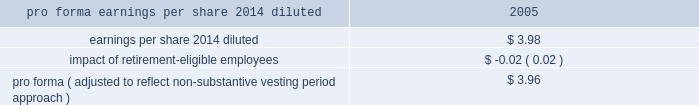The table adjusts the revised diluted earnings per share for 2005 from the preceding table to reflect the approximate impact of using the non-substantive vesting period approach for these periods .
Stock-based compensation .
Pro forma ( adjusted to reflect non-substantive vesting period approach ) $ 3.96 note 16 .
Business segments effective in the first quarter of 2007 , 3m made certain changes to its business segments in its continuing effort to drive growth by aligning businesses around markets and customers .
The most significant of these changes are summarized as follows : 2022 3m 2019s new emerging business opportunity in its track and trace initiative resulted in the merging of a number of formerly separate efforts into one concerted effort for future growth .
Track and trace has a growing array of applications 2013 from tracking packages to managing medical and legal records .
The establishment of this new initiative within 3m 2019s safety , security and protection services segment resulted in the transfer of certain businesses to this segment from other segments , including the transfer of highjump software inc. , a 3m u.s.-based subsidiary that provides supply chain execution software and solutions ( industrial and transportation segment ) and the transfer of certain track and trace products from the electro and communications segment .
2022 3m 2019s visual systems business ( consumer and office segment ) , which offers analog overhead and electronic projectors and film , was transferred to the electro and communications segment .
This transfer is intended to leverage common markets , customers , suppliers and technologies .
2022 3m 2019s industrial and transportation segment ( energy and advanced materials business ) transferred the 3m 2122 aluminum conductor composite reinforced ( accr ) electrical power cable to the electro and communications segment ( electrical markets business ) .
With an aluminum-based metal matrix at its core , the accr product increases transmission capacity for existing power lines .
The electrical markets business sells insulating , testing and connecting products to various markets , including the electric utility markets .
2022 certain adhesives and tapes in the industrial and transportation segment ( industrial adhesives and tapes business ) were transferred to the consumer and office segment ( primarily related to the construction and home improvement business and the stationery products business ) and to the electro and communications segment ( electronics markets materials business ) .
Certain maintenance-free respirator products for the consumer market in 3m 2019s safety , security and protection services segment were transferred to the consumer and office segment ( construction and home improvement business ) .
2022 3m transferred film manufacturing and supply chain operations , a resource for the manufacturing and development of films and materials , to the display and graphics business from corporate and unallocated .
The financial information presented herein reflects the impact of all of the preceding changes for all periods presented .
3m 2019s businesses are organized , managed and internally grouped into segments based on differences in products , technologies and services .
3m continues to manage its operations in six operating business segments : industrial and transportation segment , health care segment , display and graphics segment , consumer and office segment , safety , security and protection services segment and electro and communications segment .
3m 2019s six business segments bring together common or related 3m technologies , enhancing the development of innovative products and services and providing for efficient sharing of business resources .
These segments have worldwide responsibility for virtually all 3m product lines .
3m is not dependent on any single product or market .
Certain small businesses and lab-sponsored products , as well as various corporate assets and expenses , are not allocated to the business segments .
Transactions among reportable segments are recorded at cost .
3m is an integrated enterprise characterized by substantial intersegment cooperation , cost allocations and inventory transfers .
Therefore , management does not represent that these segments , if operated independently , would report the operating income and other financial information shown .
The allocations resulting from the shared utilization of assets are not necessarily indicative of the underlying activity for segment assets , depreciation and amortization , and capital expenditures. .
In 2005 what was the percent of the impact of retirement-eligible employees to earnings per share 2014 diluted? 
Rationale: the percent of the impact of retirement-eligible employees to earnings per share 2014 diluted was 0.5%
Computations: (0.02 / 3.98)
Answer: 0.00503. 